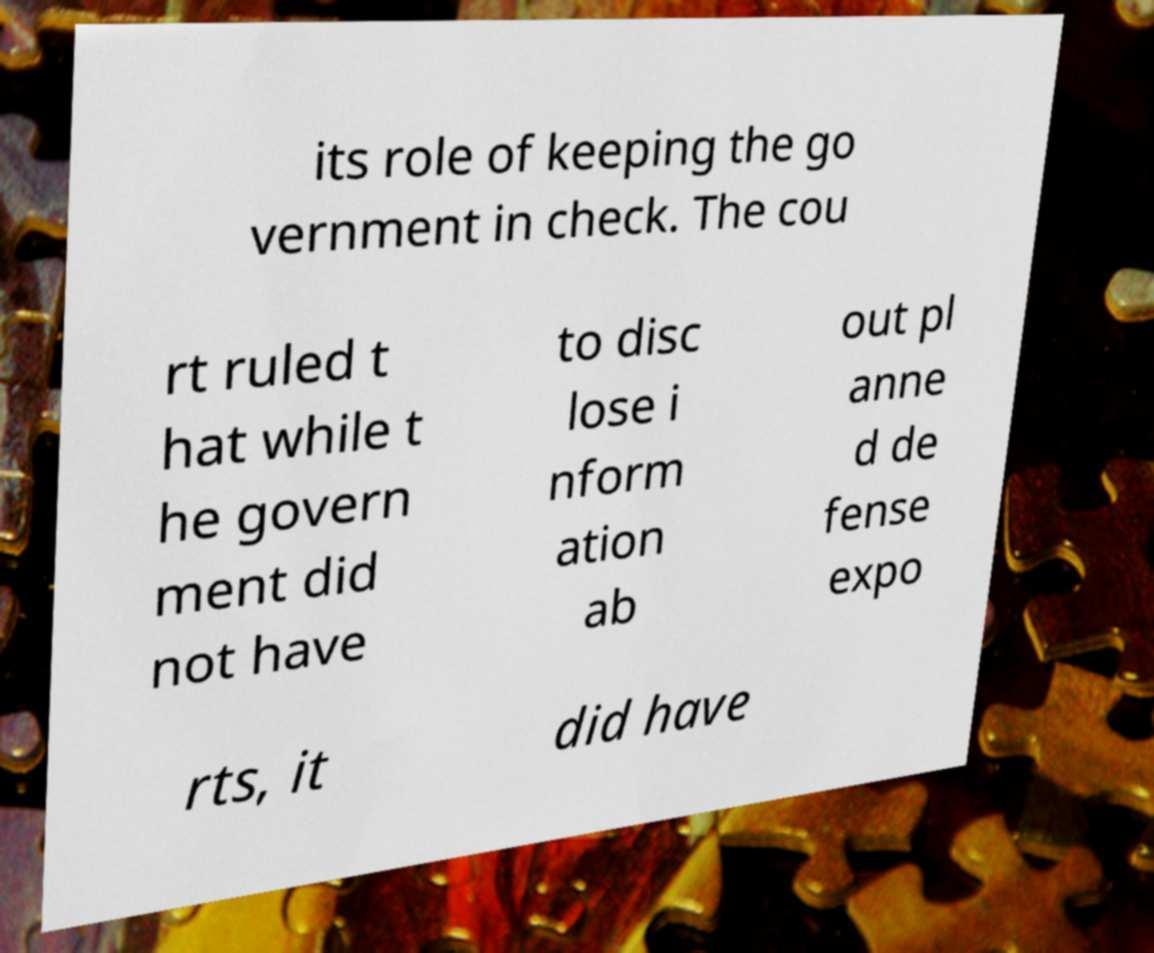I need the written content from this picture converted into text. Can you do that? its role of keeping the go vernment in check. The cou rt ruled t hat while t he govern ment did not have to disc lose i nform ation ab out pl anne d de fense expo rts, it did have 